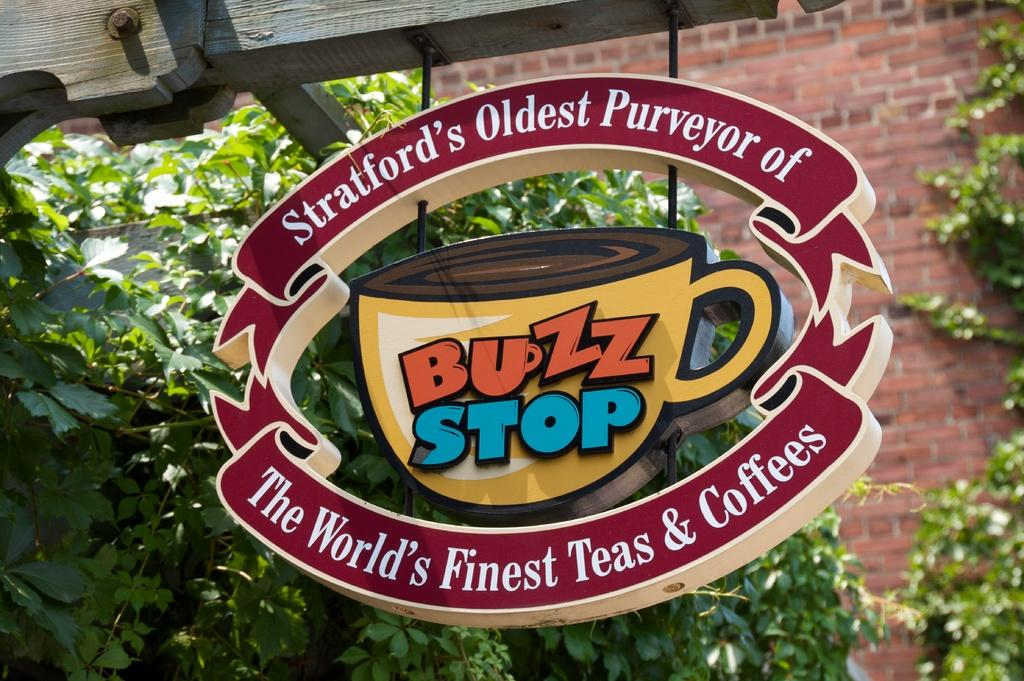What is the main object in the image? There is a board in the image. What is written or displayed on the board? The board contains text and an image of a cup. What material is the wooden object at the top of the image made of? The wooden object at the top of the image is made of wood. What can be seen in the background of the image? There is a wall and plants in the background of the image. What type of surprise can be seen in the image? There is no surprise present in the image. Is there any eggnog visible in the image? There is no eggnog present in the image. 